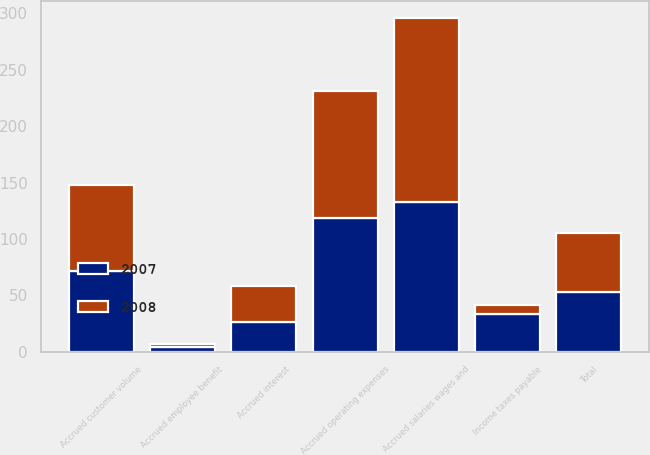Convert chart to OTSL. <chart><loc_0><loc_0><loc_500><loc_500><stacked_bar_chart><ecel><fcel>Accrued salaries wages and<fcel>Accrued operating expenses<fcel>Income taxes payable<fcel>Accrued customer volume<fcel>Accrued interest<fcel>Accrued employee benefit<fcel>Total<nl><fcel>2007<fcel>132.8<fcel>118.6<fcel>33.6<fcel>71.8<fcel>26.4<fcel>4.2<fcel>52.7<nl><fcel>2008<fcel>163.2<fcel>112.8<fcel>8<fcel>76.4<fcel>32.1<fcel>2.7<fcel>52.7<nl></chart> 